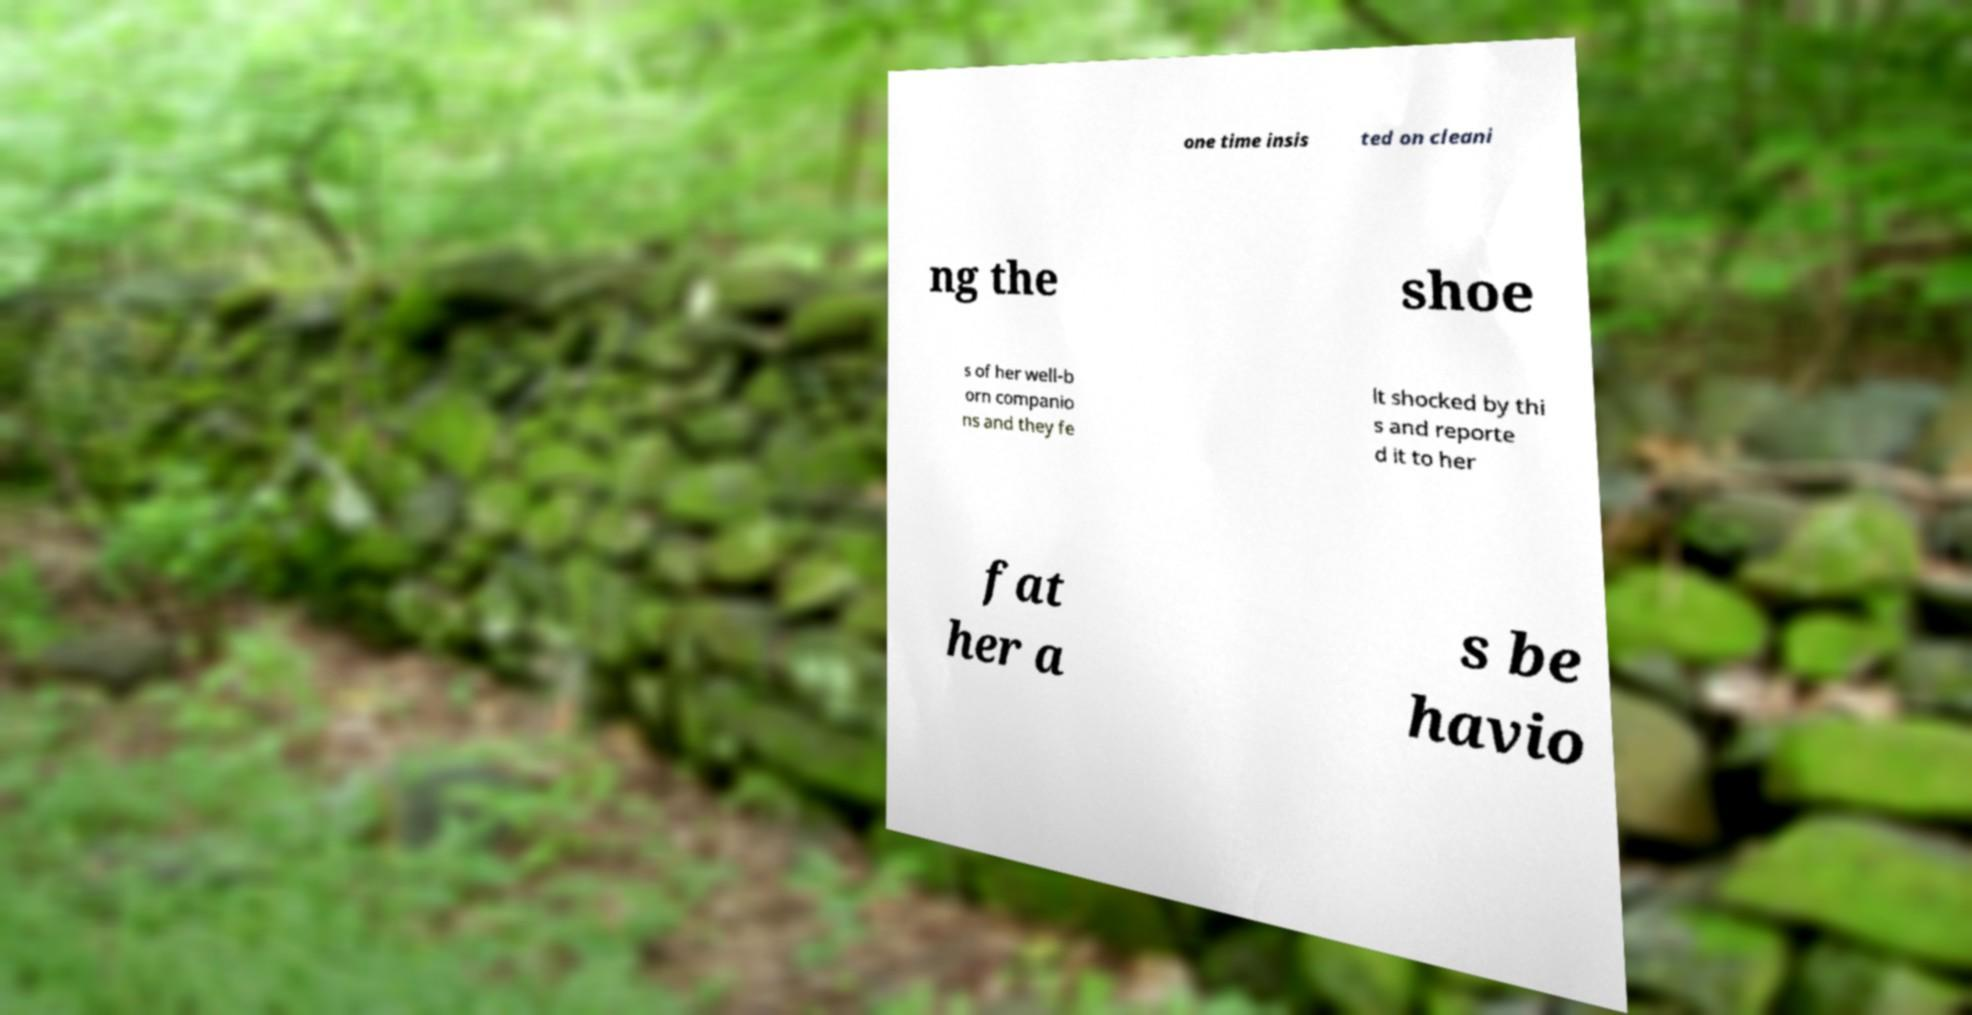Please identify and transcribe the text found in this image. one time insis ted on cleani ng the shoe s of her well-b orn companio ns and they fe lt shocked by thi s and reporte d it to her fat her a s be havio 